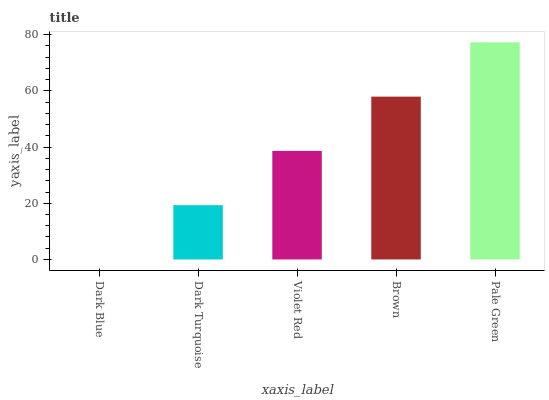Is Dark Blue the minimum?
Answer yes or no. Yes. Is Pale Green the maximum?
Answer yes or no. Yes. Is Dark Turquoise the minimum?
Answer yes or no. No. Is Dark Turquoise the maximum?
Answer yes or no. No. Is Dark Turquoise greater than Dark Blue?
Answer yes or no. Yes. Is Dark Blue less than Dark Turquoise?
Answer yes or no. Yes. Is Dark Blue greater than Dark Turquoise?
Answer yes or no. No. Is Dark Turquoise less than Dark Blue?
Answer yes or no. No. Is Violet Red the high median?
Answer yes or no. Yes. Is Violet Red the low median?
Answer yes or no. Yes. Is Dark Turquoise the high median?
Answer yes or no. No. Is Dark Turquoise the low median?
Answer yes or no. No. 